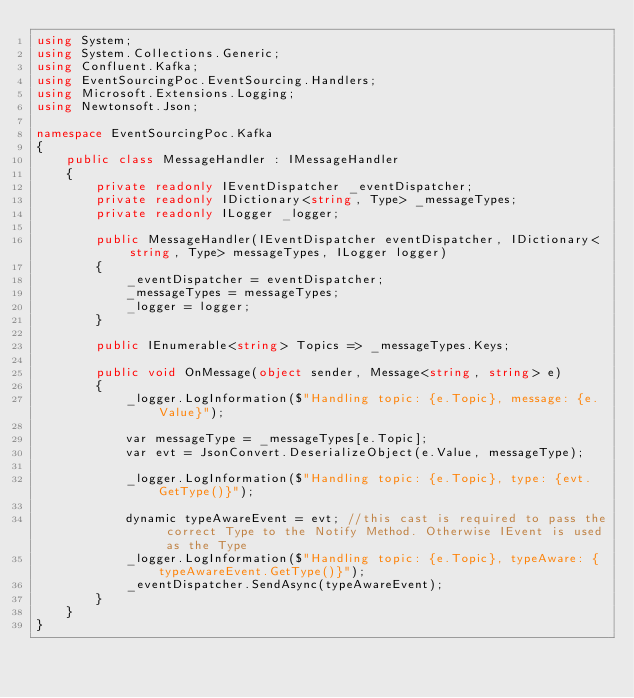<code> <loc_0><loc_0><loc_500><loc_500><_C#_>using System;
using System.Collections.Generic;
using Confluent.Kafka;
using EventSourcingPoc.EventSourcing.Handlers;
using Microsoft.Extensions.Logging;
using Newtonsoft.Json;

namespace EventSourcingPoc.Kafka
{
    public class MessageHandler : IMessageHandler
    {
        private readonly IEventDispatcher _eventDispatcher;
        private readonly IDictionary<string, Type> _messageTypes;
        private readonly ILogger _logger;

        public MessageHandler(IEventDispatcher eventDispatcher, IDictionary<string, Type> messageTypes, ILogger logger)
        {
            _eventDispatcher = eventDispatcher;
            _messageTypes = messageTypes;
            _logger = logger;
        }

        public IEnumerable<string> Topics => _messageTypes.Keys;

        public void OnMessage(object sender, Message<string, string> e)
        {
            _logger.LogInformation($"Handling topic: {e.Topic}, message: {e.Value}");

            var messageType = _messageTypes[e.Topic];
            var evt = JsonConvert.DeserializeObject(e.Value, messageType);

            _logger.LogInformation($"Handling topic: {e.Topic}, type: {evt.GetType()}");

            dynamic typeAwareEvent = evt; //this cast is required to pass the correct Type to the Notify Method. Otherwise IEvent is used as the Type
            _logger.LogInformation($"Handling topic: {e.Topic}, typeAware: {typeAwareEvent.GetType()}");
            _eventDispatcher.SendAsync(typeAwareEvent);
        }
    }
}
</code> 